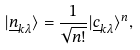Convert formula to latex. <formula><loc_0><loc_0><loc_500><loc_500>| \underline { n } _ { k \lambda } \rangle = \frac { 1 } { \sqrt { n ! } } | \underline { c } _ { k \lambda } \rangle ^ { n } ,</formula> 